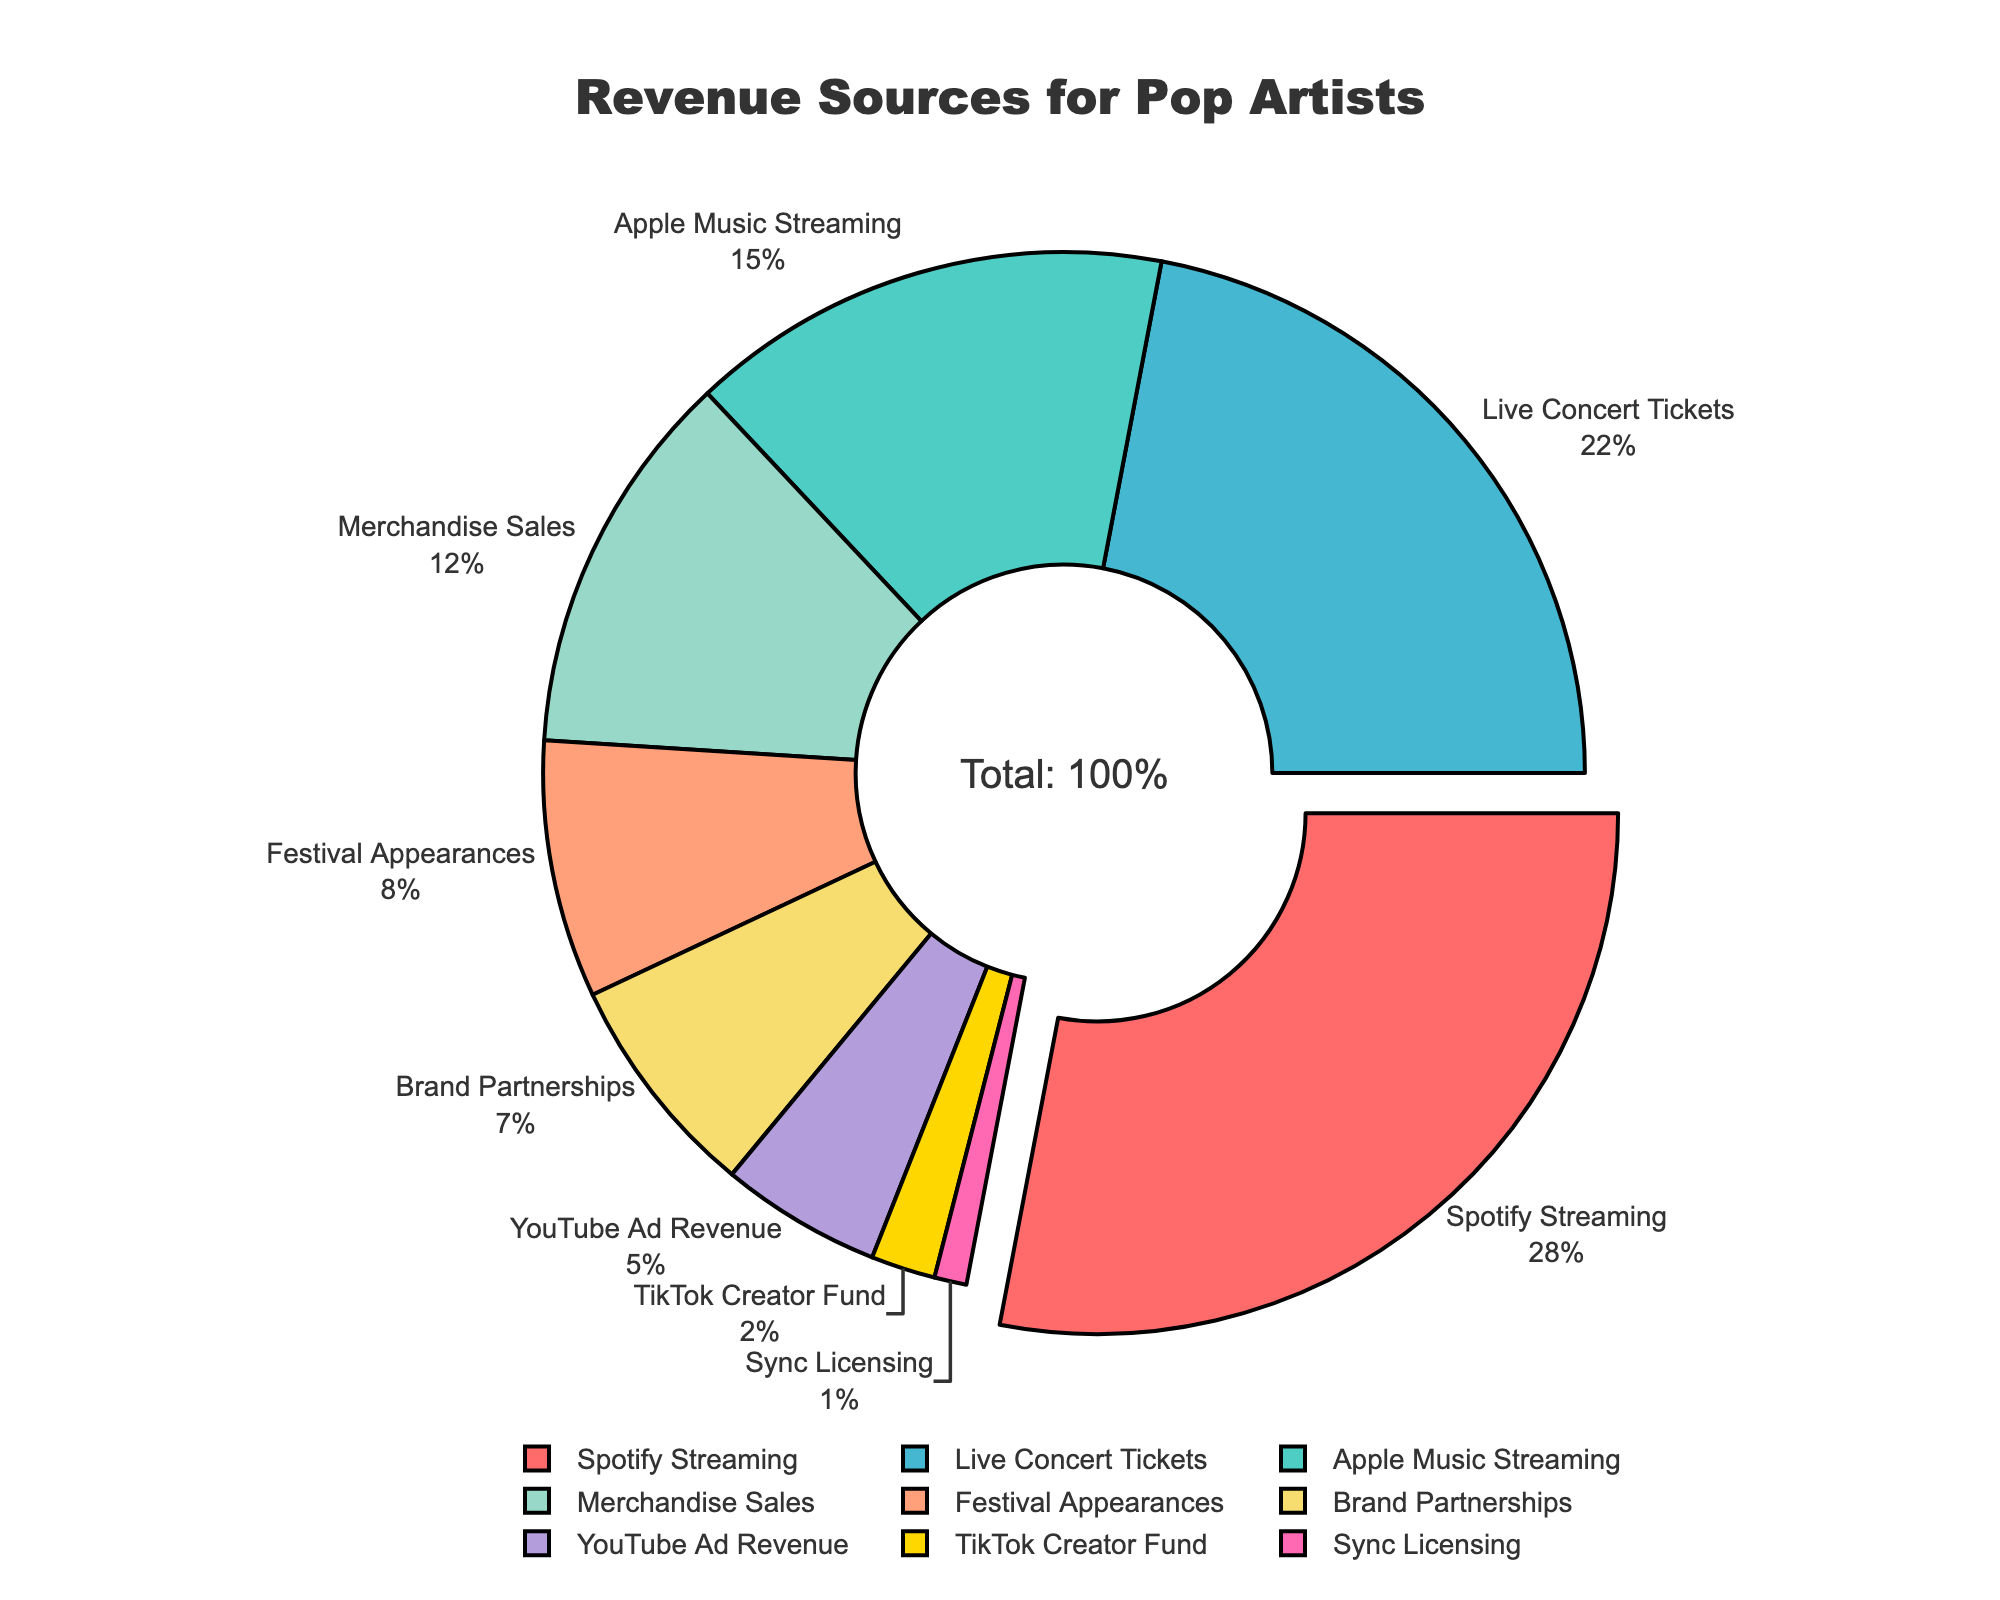What's the largest revenue source for pop artists according to the figure? The largest revenue source can be determined by the largest segment in the pie chart, which is also slightly pulled out for emphasis. The label shows that this segment represents Spotify Streaming with 28%.
Answer: Spotify Streaming Which two revenue sources combined contribute more: Live Concert Tickets and Merchandise Sales, or Apple Music Streaming and Festival Appearances? Live Concert Tickets contribute 22% and Merchandise Sales contribute 12%, giving a total of 22 + 12 = 34%. Apple Music Streaming contributes 15% and Festival Appearances contribute 8%, giving a total of 15 + 8 = 23%. Therefore, Live Concert Tickets and Merchandise Sales combined contribute more.
Answer: Live Concert Tickets and Merchandise Sales What is the percentage difference between YouTube Ad Revenue and Sync Licensing? YouTube Ad Revenue contributes 5% and Sync Licensing contributes 1%. The percentage difference is calculated as 5% - 1% = 4%.
Answer: 4% Which revenue source has the smallest contribution, and what is the percentage? The smallest segment in the pie chart represents Sync Licensing, contributing 1%.
Answer: Sync Licensing, 1% What percentage of revenue is generated from streaming sources (both Spotify and Apple Music)? Spotify Streaming contributes 28% and Apple Music Streaming contributes 15%. The combined streaming revenue is 28% + 15% = 43%.
Answer: 43% How does the revenue from Brand Partnerships compare with that from TikTok Creator Fund? Brand Partnerships contribute 7%, while TikTok Creator Fund contributes 2%. Therefore, Brand Partnerships contribute more than TikTok Creator Fund.
Answer: Brand Partnerships contribute more If we combine the percentages of Festival Appearances, YouTube Ad Revenue, and TikTok Creator Fund, what is the total? Festival Appearances contribute 8%, YouTube Ad Revenue contributes 5%, and TikTok Creator Fund contributes 2%. Therefore, the total is 8% + 5% + 2% = 15%.
Answer: 15% Which revenue source is visually represented by the color red? By observing the color legend in the pie chart, the red segment represents Spotify Streaming.
Answer: Spotify Streaming 